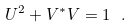<formula> <loc_0><loc_0><loc_500><loc_500>U ^ { 2 } + V ^ { * } V = 1 \ .</formula> 